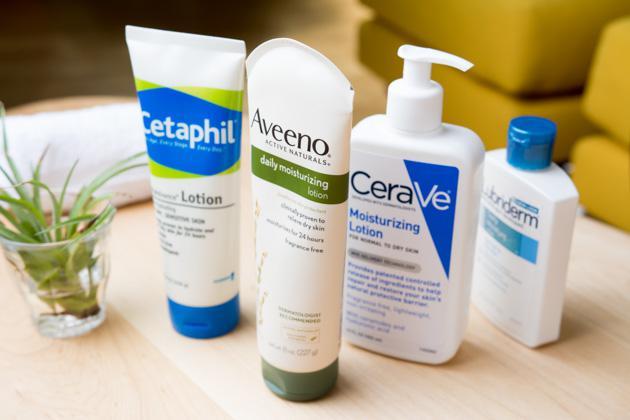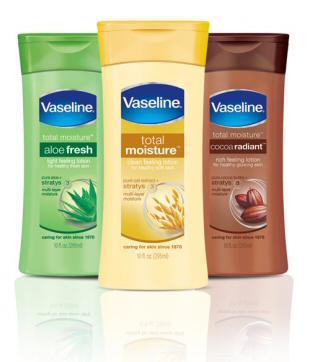The first image is the image on the left, the second image is the image on the right. Given the left and right images, does the statement "One image shows exactly three skincare products, which are in a row and upright." hold true? Answer yes or no. Yes. The first image is the image on the left, the second image is the image on the right. Evaluate the accuracy of this statement regarding the images: "Three containers are shown in one of the images.". Is it true? Answer yes or no. Yes. 